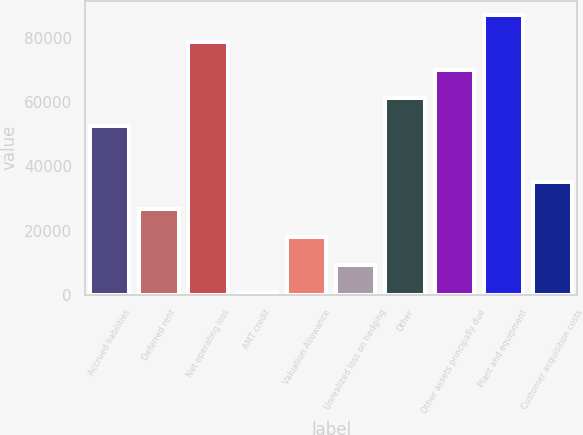<chart> <loc_0><loc_0><loc_500><loc_500><bar_chart><fcel>Accrued liabilities<fcel>Deferred rent<fcel>Net operating loss<fcel>AMT credit<fcel>Valuation Allowance<fcel>Unrealized loss on hedging<fcel>Other<fcel>Other assets principally due<fcel>Plant and equipment<fcel>Customer acquisition costs<nl><fcel>52659.8<fcel>26623.4<fcel>78696.2<fcel>587<fcel>17944.6<fcel>9265.8<fcel>61338.6<fcel>70017.4<fcel>87375<fcel>35302.2<nl></chart> 